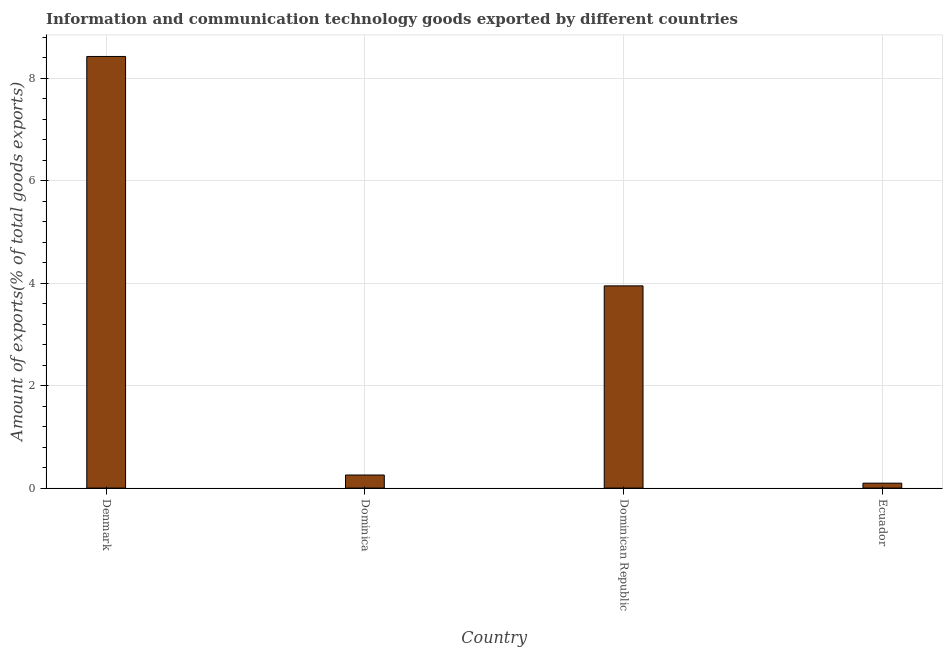What is the title of the graph?
Your response must be concise. Information and communication technology goods exported by different countries. What is the label or title of the Y-axis?
Provide a succinct answer. Amount of exports(% of total goods exports). What is the amount of ict goods exports in Dominica?
Your answer should be very brief. 0.26. Across all countries, what is the maximum amount of ict goods exports?
Keep it short and to the point. 8.43. Across all countries, what is the minimum amount of ict goods exports?
Make the answer very short. 0.1. In which country was the amount of ict goods exports minimum?
Your response must be concise. Ecuador. What is the sum of the amount of ict goods exports?
Provide a short and direct response. 12.72. What is the difference between the amount of ict goods exports in Denmark and Ecuador?
Keep it short and to the point. 8.33. What is the average amount of ict goods exports per country?
Keep it short and to the point. 3.18. What is the median amount of ict goods exports?
Provide a short and direct response. 2.1. What is the ratio of the amount of ict goods exports in Denmark to that in Dominican Republic?
Offer a very short reply. 2.13. Is the amount of ict goods exports in Denmark less than that in Dominican Republic?
Keep it short and to the point. No. Is the difference between the amount of ict goods exports in Dominican Republic and Ecuador greater than the difference between any two countries?
Your answer should be very brief. No. What is the difference between the highest and the second highest amount of ict goods exports?
Ensure brevity in your answer.  4.48. What is the difference between the highest and the lowest amount of ict goods exports?
Your answer should be compact. 8.33. In how many countries, is the amount of ict goods exports greater than the average amount of ict goods exports taken over all countries?
Provide a succinct answer. 2. How many bars are there?
Offer a very short reply. 4. Are all the bars in the graph horizontal?
Give a very brief answer. No. How many countries are there in the graph?
Your response must be concise. 4. What is the difference between two consecutive major ticks on the Y-axis?
Offer a very short reply. 2. Are the values on the major ticks of Y-axis written in scientific E-notation?
Provide a succinct answer. No. What is the Amount of exports(% of total goods exports) in Denmark?
Provide a succinct answer. 8.43. What is the Amount of exports(% of total goods exports) in Dominica?
Your answer should be very brief. 0.26. What is the Amount of exports(% of total goods exports) in Dominican Republic?
Provide a short and direct response. 3.95. What is the Amount of exports(% of total goods exports) of Ecuador?
Offer a terse response. 0.1. What is the difference between the Amount of exports(% of total goods exports) in Denmark and Dominica?
Give a very brief answer. 8.17. What is the difference between the Amount of exports(% of total goods exports) in Denmark and Dominican Republic?
Offer a very short reply. 4.48. What is the difference between the Amount of exports(% of total goods exports) in Denmark and Ecuador?
Provide a short and direct response. 8.33. What is the difference between the Amount of exports(% of total goods exports) in Dominica and Dominican Republic?
Your answer should be very brief. -3.69. What is the difference between the Amount of exports(% of total goods exports) in Dominica and Ecuador?
Keep it short and to the point. 0.16. What is the difference between the Amount of exports(% of total goods exports) in Dominican Republic and Ecuador?
Make the answer very short. 3.85. What is the ratio of the Amount of exports(% of total goods exports) in Denmark to that in Dominica?
Offer a very short reply. 32.99. What is the ratio of the Amount of exports(% of total goods exports) in Denmark to that in Dominican Republic?
Your answer should be very brief. 2.13. What is the ratio of the Amount of exports(% of total goods exports) in Denmark to that in Ecuador?
Ensure brevity in your answer.  87.73. What is the ratio of the Amount of exports(% of total goods exports) in Dominica to that in Dominican Republic?
Ensure brevity in your answer.  0.07. What is the ratio of the Amount of exports(% of total goods exports) in Dominica to that in Ecuador?
Give a very brief answer. 2.66. What is the ratio of the Amount of exports(% of total goods exports) in Dominican Republic to that in Ecuador?
Offer a terse response. 41.1. 